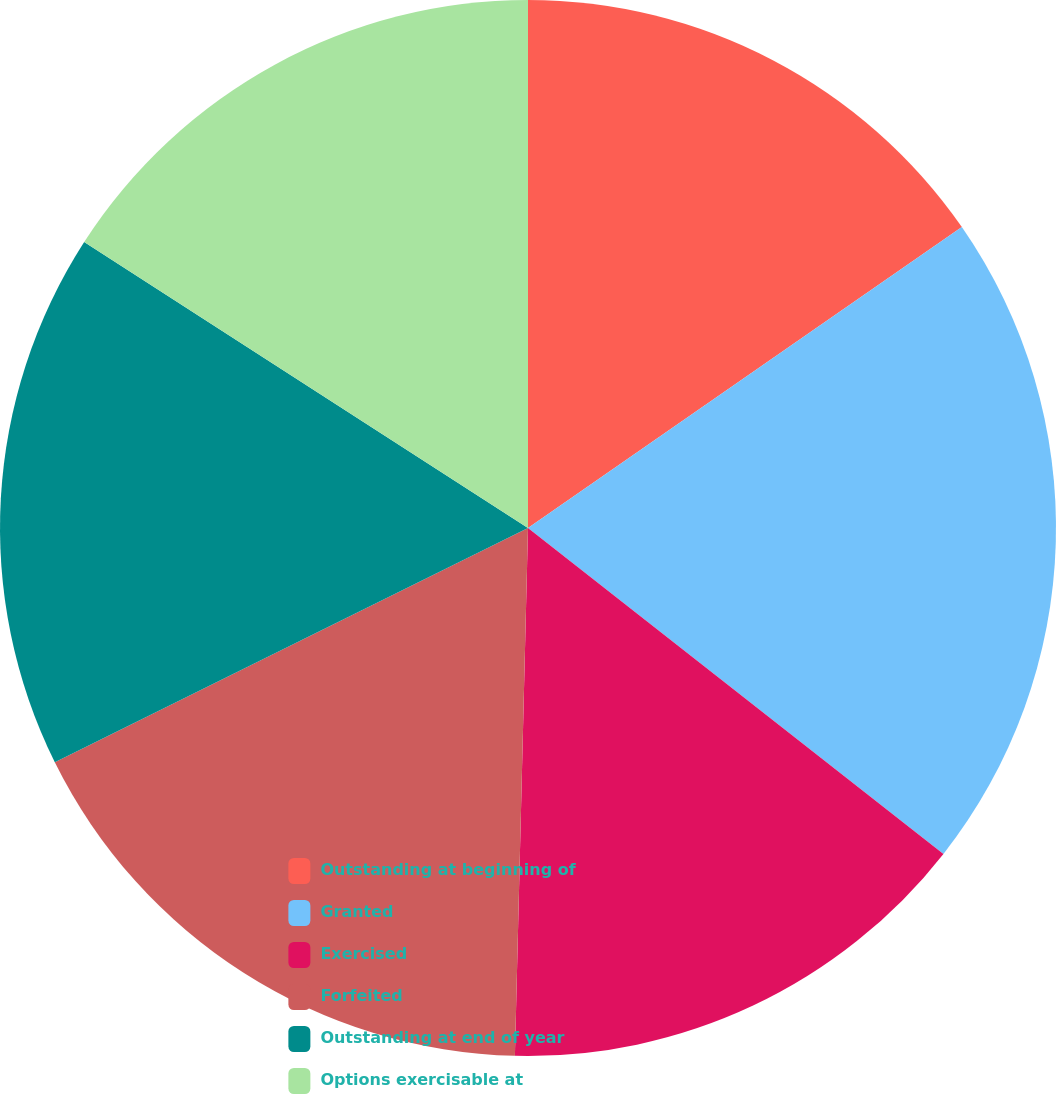Convert chart. <chart><loc_0><loc_0><loc_500><loc_500><pie_chart><fcel>Outstanding at beginning of<fcel>Granted<fcel>Exercised<fcel>Forfeited<fcel>Outstanding at end of year<fcel>Options exercisable at<nl><fcel>15.35%<fcel>20.24%<fcel>14.81%<fcel>17.29%<fcel>16.43%<fcel>15.89%<nl></chart> 